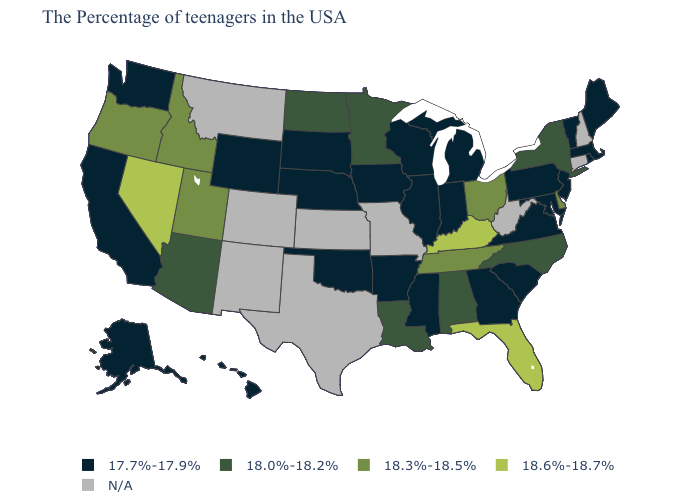Name the states that have a value in the range 18.3%-18.5%?
Write a very short answer. Delaware, Ohio, Tennessee, Utah, Idaho, Oregon. Does the first symbol in the legend represent the smallest category?
Concise answer only. Yes. Which states have the lowest value in the USA?
Give a very brief answer. Maine, Massachusetts, Rhode Island, Vermont, New Jersey, Maryland, Pennsylvania, Virginia, South Carolina, Georgia, Michigan, Indiana, Wisconsin, Illinois, Mississippi, Arkansas, Iowa, Nebraska, Oklahoma, South Dakota, Wyoming, California, Washington, Alaska, Hawaii. Name the states that have a value in the range N/A?
Concise answer only. New Hampshire, Connecticut, West Virginia, Missouri, Kansas, Texas, Colorado, New Mexico, Montana. What is the value of Illinois?
Concise answer only. 17.7%-17.9%. What is the value of Kansas?
Short answer required. N/A. Among the states that border Colorado , does Nebraska have the highest value?
Quick response, please. No. Does the map have missing data?
Give a very brief answer. Yes. Among the states that border Pennsylvania , which have the lowest value?
Give a very brief answer. New Jersey, Maryland. Which states have the lowest value in the USA?
Concise answer only. Maine, Massachusetts, Rhode Island, Vermont, New Jersey, Maryland, Pennsylvania, Virginia, South Carolina, Georgia, Michigan, Indiana, Wisconsin, Illinois, Mississippi, Arkansas, Iowa, Nebraska, Oklahoma, South Dakota, Wyoming, California, Washington, Alaska, Hawaii. What is the value of Oregon?
Write a very short answer. 18.3%-18.5%. Does South Carolina have the lowest value in the USA?
Give a very brief answer. Yes. What is the lowest value in the Northeast?
Write a very short answer. 17.7%-17.9%. What is the highest value in states that border Wisconsin?
Be succinct. 18.0%-18.2%. Among the states that border Tennessee , which have the highest value?
Keep it brief. Kentucky. 